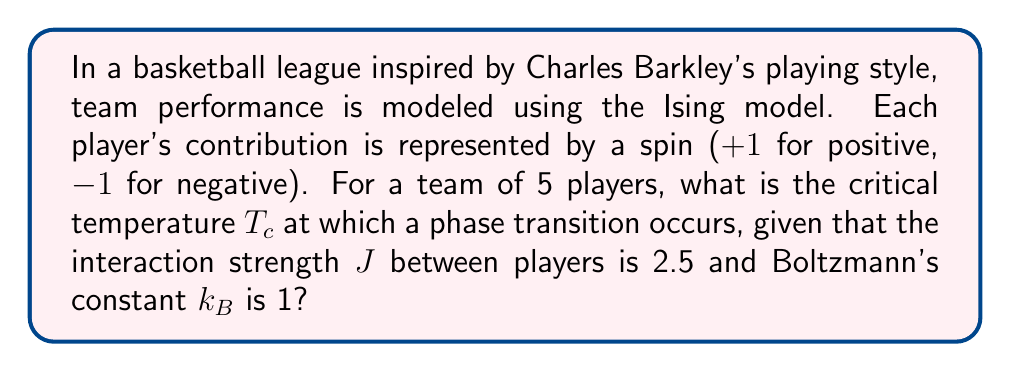Show me your answer to this math problem. To solve this problem, we'll use the Ising model applied to team performance:

1) In the mean-field approximation, the critical temperature $T_c$ for an Ising model is given by:

   $$T_c = \frac{zJ}{k_B}$$

   where $z$ is the number of nearest neighbors, $J$ is the interaction strength, and $k_B$ is Boltzmann's constant.

2) In a team of 5 players, each player interacts with all other players. So, the number of nearest neighbors for each player is 4.

3) Given:
   - $z = 4$ (number of teammates each player interacts with)
   - $J = 2.5$ (interaction strength)
   - $k_B = 1$ (Boltzmann's constant)

4) Substituting these values into the equation:

   $$T_c = \frac{4 \times 2.5}{1} = 10$$

5) Therefore, the critical temperature at which the phase transition occurs is 10 (in units of $k_B$).

This temperature represents the point at which the team's performance undergoes a significant change, transitioning from a disordered state (where player contributions are random) to an ordered state (where player contributions are aligned).
Answer: $T_c = 10$ 